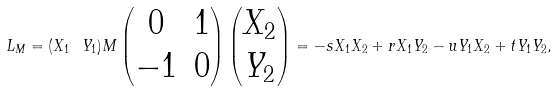Convert formula to latex. <formula><loc_0><loc_0><loc_500><loc_500>L _ { M } = ( X _ { 1 } \ Y _ { 1 } ) M \begin{pmatrix} 0 & 1 \\ - 1 & 0 \end{pmatrix} \begin{pmatrix} X _ { 2 } \\ Y _ { 2 } \end{pmatrix} = - s X _ { 1 } X _ { 2 } + r X _ { 1 } Y _ { 2 } - u Y _ { 1 } X _ { 2 } + t Y _ { 1 } Y _ { 2 } ,</formula> 